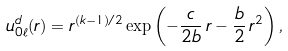Convert formula to latex. <formula><loc_0><loc_0><loc_500><loc_500>u _ { 0 \ell } ^ { d } ( r ) = r ^ { ( k - 1 ) / 2 } \exp \left ( - \frac { c } { 2 b } \, r - \frac { b } { 2 } \, r ^ { 2 } \right ) ,</formula> 